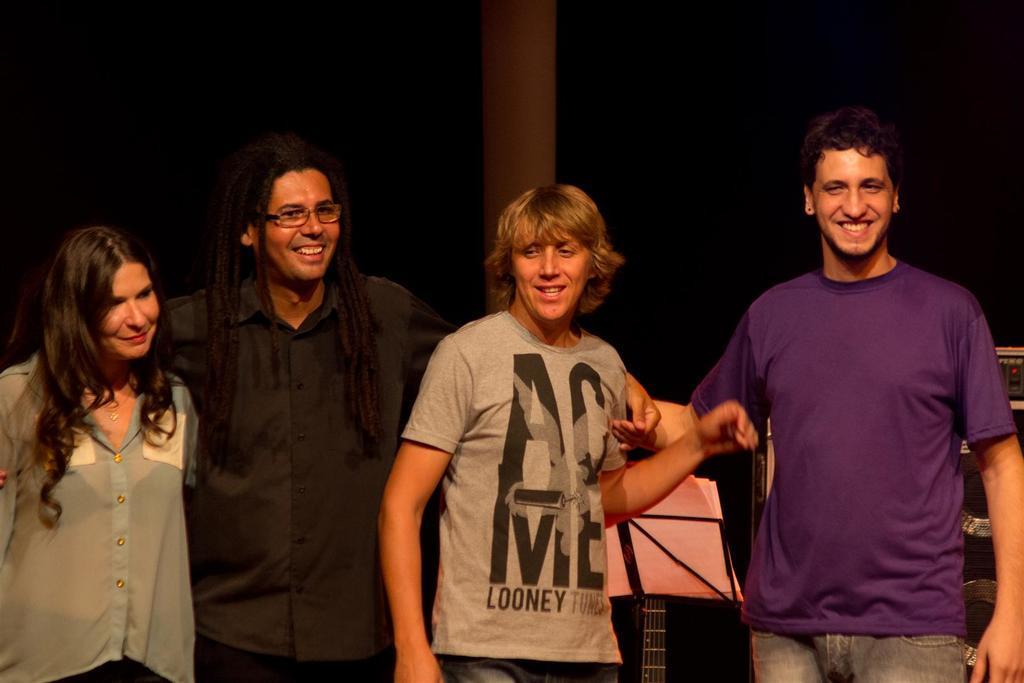Describe this image in one or two sentences. In the center of the image there are people standing. There is a pillar at the background of the image. 